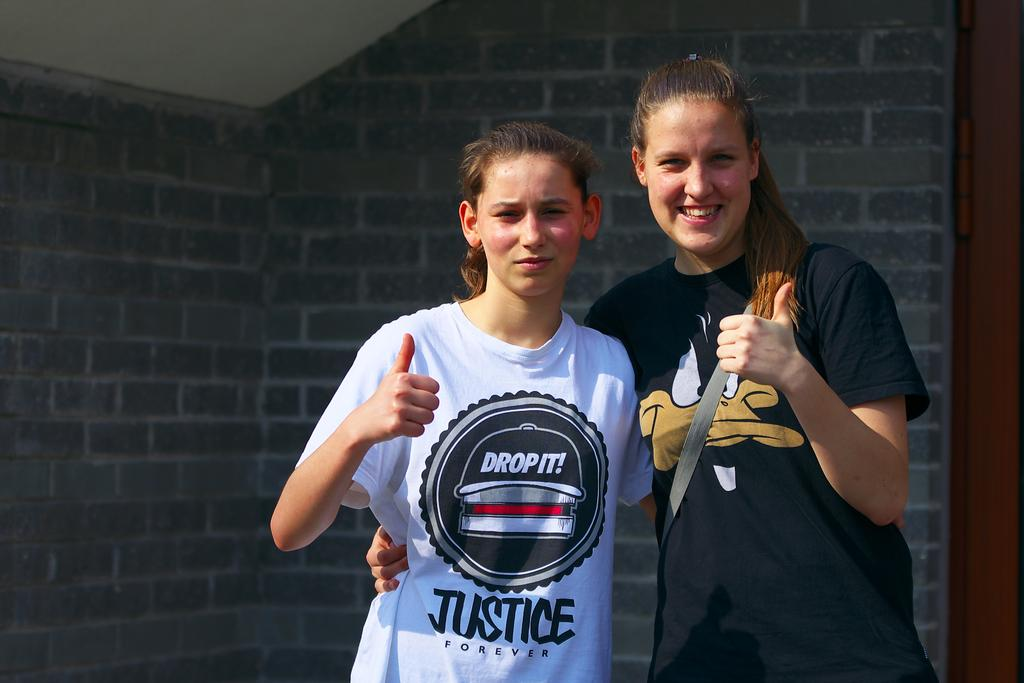<image>
Render a clear and concise summary of the photo. Two girls are posing together with their thumbs up and one has a shirt that says Justice Forever. 